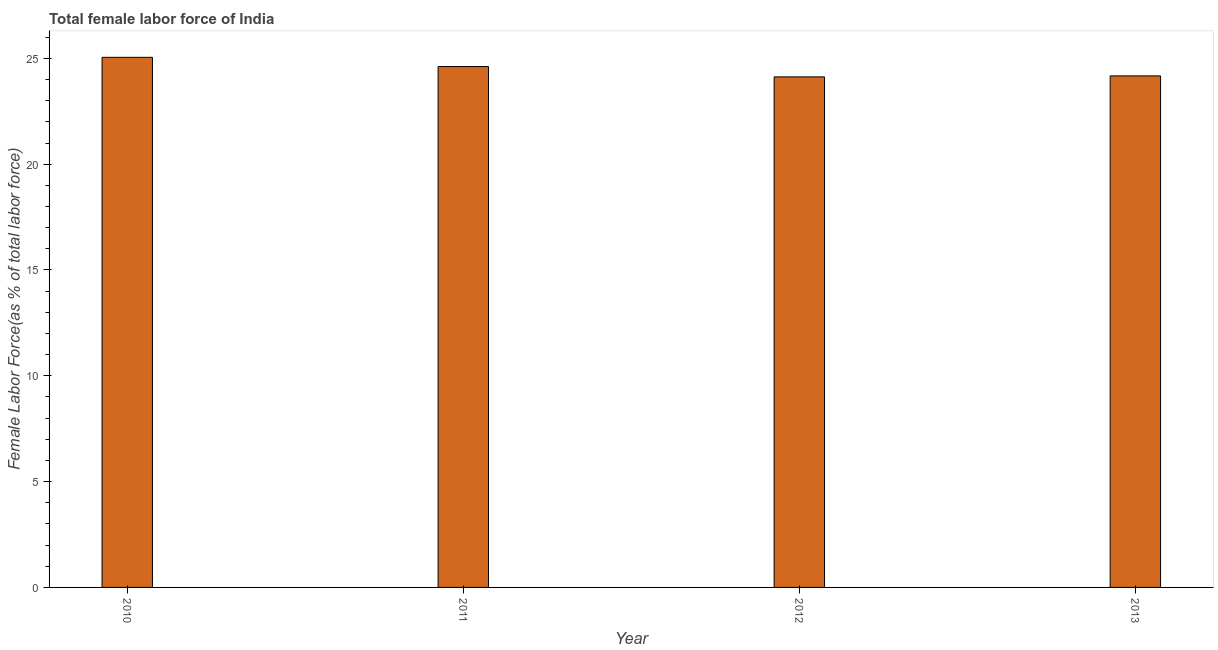Does the graph contain grids?
Keep it short and to the point. No. What is the title of the graph?
Give a very brief answer. Total female labor force of India. What is the label or title of the Y-axis?
Offer a very short reply. Female Labor Force(as % of total labor force). What is the total female labor force in 2010?
Ensure brevity in your answer.  25.05. Across all years, what is the maximum total female labor force?
Your answer should be very brief. 25.05. Across all years, what is the minimum total female labor force?
Provide a short and direct response. 24.12. In which year was the total female labor force maximum?
Provide a short and direct response. 2010. What is the sum of the total female labor force?
Give a very brief answer. 97.96. What is the difference between the total female labor force in 2011 and 2012?
Offer a terse response. 0.49. What is the average total female labor force per year?
Offer a terse response. 24.49. What is the median total female labor force?
Give a very brief answer. 24.39. Do a majority of the years between 2011 and 2013 (inclusive) have total female labor force greater than 5 %?
Make the answer very short. Yes. What is the ratio of the total female labor force in 2012 to that in 2013?
Provide a short and direct response. 1. What is the difference between the highest and the second highest total female labor force?
Your response must be concise. 0.43. How many years are there in the graph?
Keep it short and to the point. 4. What is the difference between two consecutive major ticks on the Y-axis?
Your answer should be very brief. 5. What is the Female Labor Force(as % of total labor force) in 2010?
Make the answer very short. 25.05. What is the Female Labor Force(as % of total labor force) in 2011?
Your answer should be very brief. 24.61. What is the Female Labor Force(as % of total labor force) of 2012?
Give a very brief answer. 24.12. What is the Female Labor Force(as % of total labor force) in 2013?
Make the answer very short. 24.17. What is the difference between the Female Labor Force(as % of total labor force) in 2010 and 2011?
Keep it short and to the point. 0.44. What is the difference between the Female Labor Force(as % of total labor force) in 2010 and 2012?
Offer a very short reply. 0.92. What is the difference between the Female Labor Force(as % of total labor force) in 2010 and 2013?
Offer a terse response. 0.88. What is the difference between the Female Labor Force(as % of total labor force) in 2011 and 2012?
Provide a short and direct response. 0.49. What is the difference between the Female Labor Force(as % of total labor force) in 2011 and 2013?
Make the answer very short. 0.44. What is the difference between the Female Labor Force(as % of total labor force) in 2012 and 2013?
Offer a terse response. -0.05. What is the ratio of the Female Labor Force(as % of total labor force) in 2010 to that in 2011?
Ensure brevity in your answer.  1.02. What is the ratio of the Female Labor Force(as % of total labor force) in 2010 to that in 2012?
Your answer should be compact. 1.04. What is the ratio of the Female Labor Force(as % of total labor force) in 2010 to that in 2013?
Ensure brevity in your answer.  1.04. What is the ratio of the Female Labor Force(as % of total labor force) in 2011 to that in 2013?
Keep it short and to the point. 1.02. 